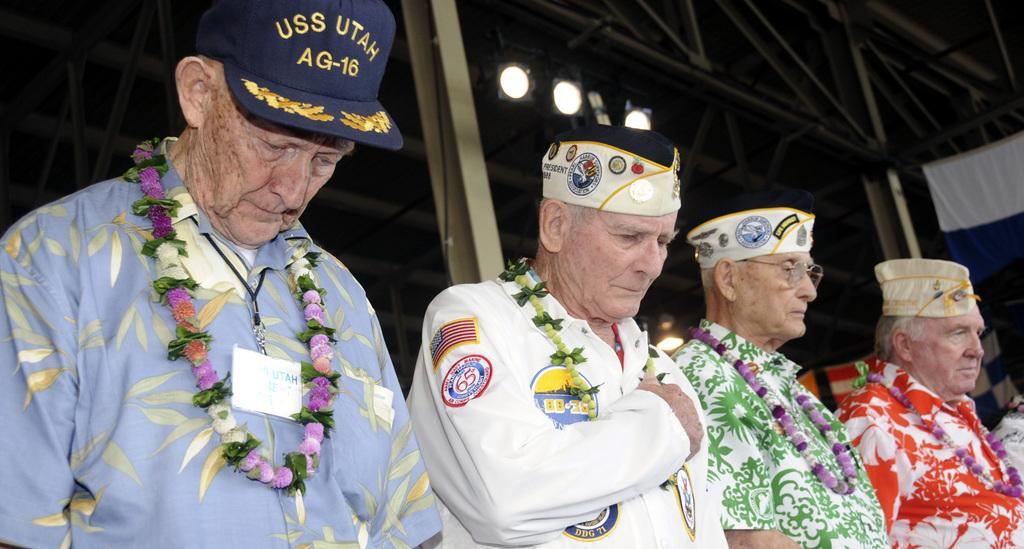What are the people in the image wearing? The people in the image are wearing garlands. What can be seen in the background of the image? There are lights and poles in the background of the image. What is located on the left side of the image? There are objects on the left side of the image. What type of amusement can be seen blowing in the wind in the image? There is no amusement blowing in the wind in the image. How many eggs are visible in the image? There are no eggs present in the image. 